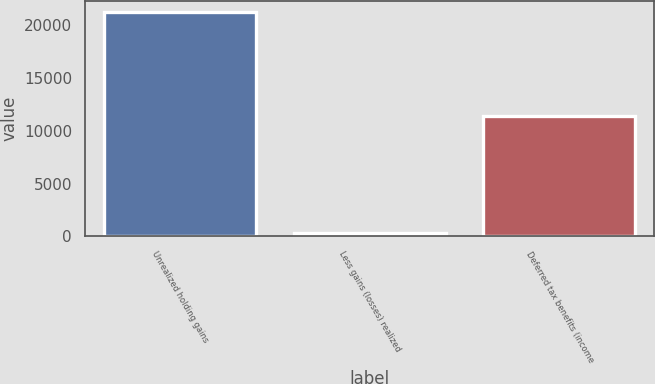Convert chart to OTSL. <chart><loc_0><loc_0><loc_500><loc_500><bar_chart><fcel>Unrealized holding gains<fcel>Less gains (losses) realized<fcel>Deferred tax benefits (income<nl><fcel>21250<fcel>332<fcel>11447<nl></chart> 